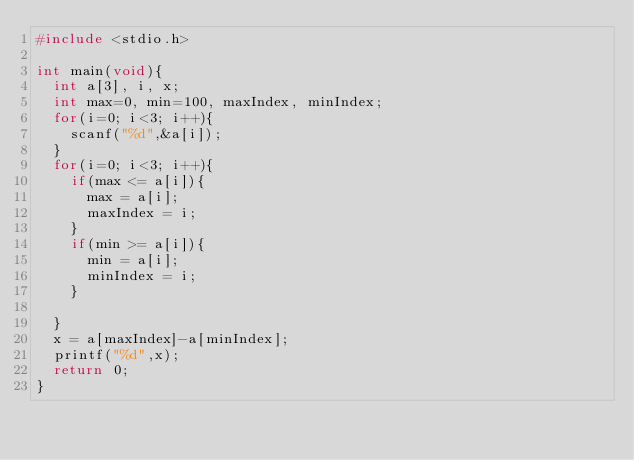Convert code to text. <code><loc_0><loc_0><loc_500><loc_500><_C_>#include <stdio.h>

int main(void){
  int a[3], i, x;
  int max=0, min=100, maxIndex, minIndex;
  for(i=0; i<3; i++){
    scanf("%d",&a[i]);
  }
  for(i=0; i<3; i++){
    if(max <= a[i]){
      max = a[i]; 
      maxIndex = i;
    }
    if(min >= a[i]){
      min = a[i];
      minIndex = i;
    }
    
  }
  x = a[maxIndex]-a[minIndex];
  printf("%d",x);
  return 0;
}</code> 